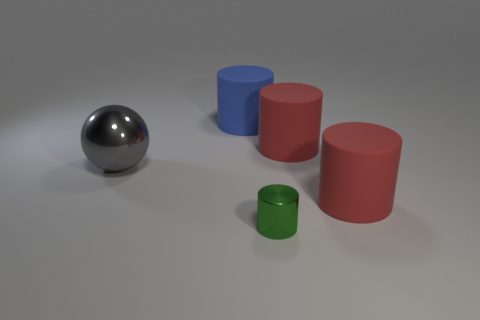There is a green metallic cylinder; are there any green metal things behind it?
Provide a short and direct response. No. Do the cylinder to the left of the metallic cylinder and the matte cylinder in front of the large gray ball have the same size?
Ensure brevity in your answer.  Yes. Are there any blue blocks of the same size as the gray object?
Keep it short and to the point. No. There is a red object in front of the large metal ball; is it the same shape as the big blue thing?
Give a very brief answer. Yes. There is a big cylinder left of the green metal thing; what is its material?
Offer a very short reply. Rubber. What is the shape of the metal object on the left side of the matte cylinder left of the small green cylinder?
Your answer should be compact. Sphere. There is a blue thing; is its shape the same as the shiny thing to the left of the tiny metallic thing?
Provide a short and direct response. No. There is a metal object behind the tiny green thing; what number of green metallic things are behind it?
Make the answer very short. 0. There is a big blue thing that is the same shape as the green object; what is its material?
Your answer should be compact. Rubber. How many yellow objects are either large balls or large rubber objects?
Provide a succinct answer. 0. 